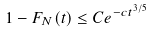Convert formula to latex. <formula><loc_0><loc_0><loc_500><loc_500>1 - F _ { N } ( t ) \leq C e ^ { - c t ^ { 3 / 5 } }</formula> 